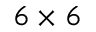<formula> <loc_0><loc_0><loc_500><loc_500>6 \times 6</formula> 